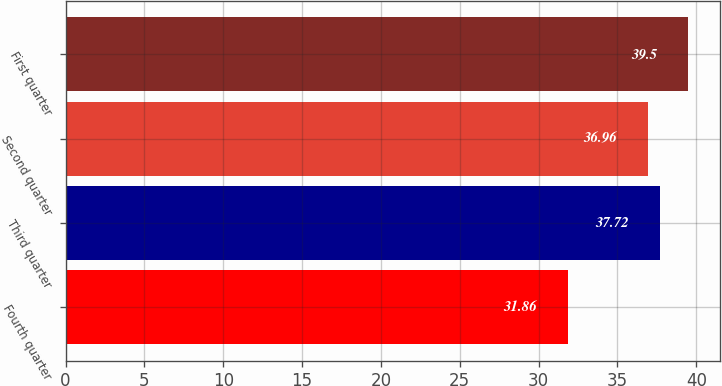<chart> <loc_0><loc_0><loc_500><loc_500><bar_chart><fcel>Fourth quarter<fcel>Third quarter<fcel>Second quarter<fcel>First quarter<nl><fcel>31.86<fcel>37.72<fcel>36.96<fcel>39.5<nl></chart> 